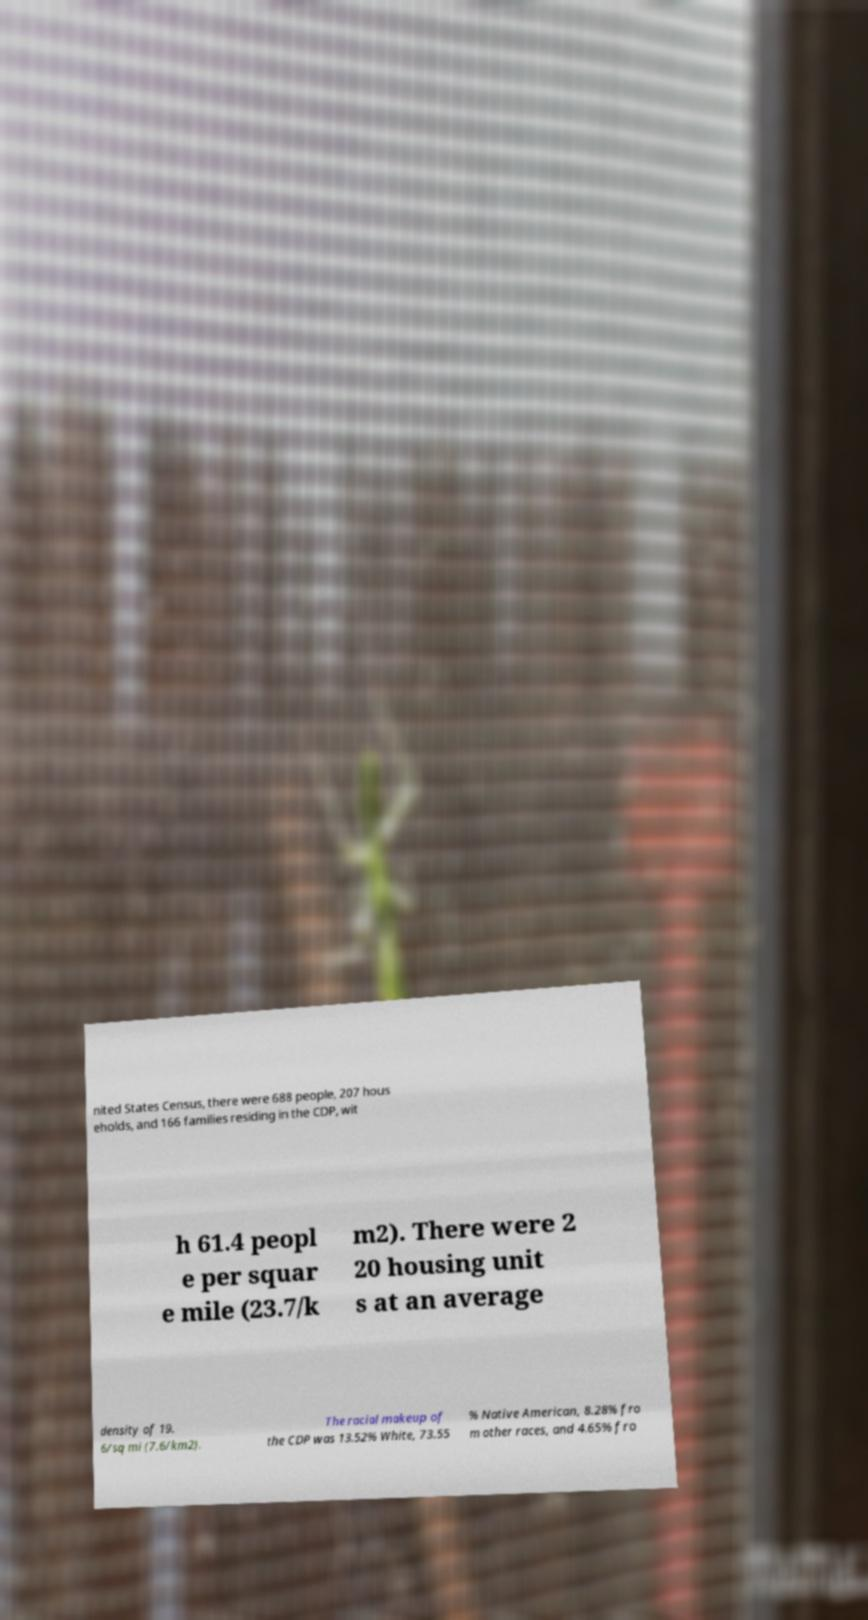Please read and relay the text visible in this image. What does it say? nited States Census, there were 688 people, 207 hous eholds, and 166 families residing in the CDP, wit h 61.4 peopl e per squar e mile (23.7/k m2). There were 2 20 housing unit s at an average density of 19. 6/sq mi (7.6/km2). The racial makeup of the CDP was 13.52% White, 73.55 % Native American, 8.28% fro m other races, and 4.65% fro 